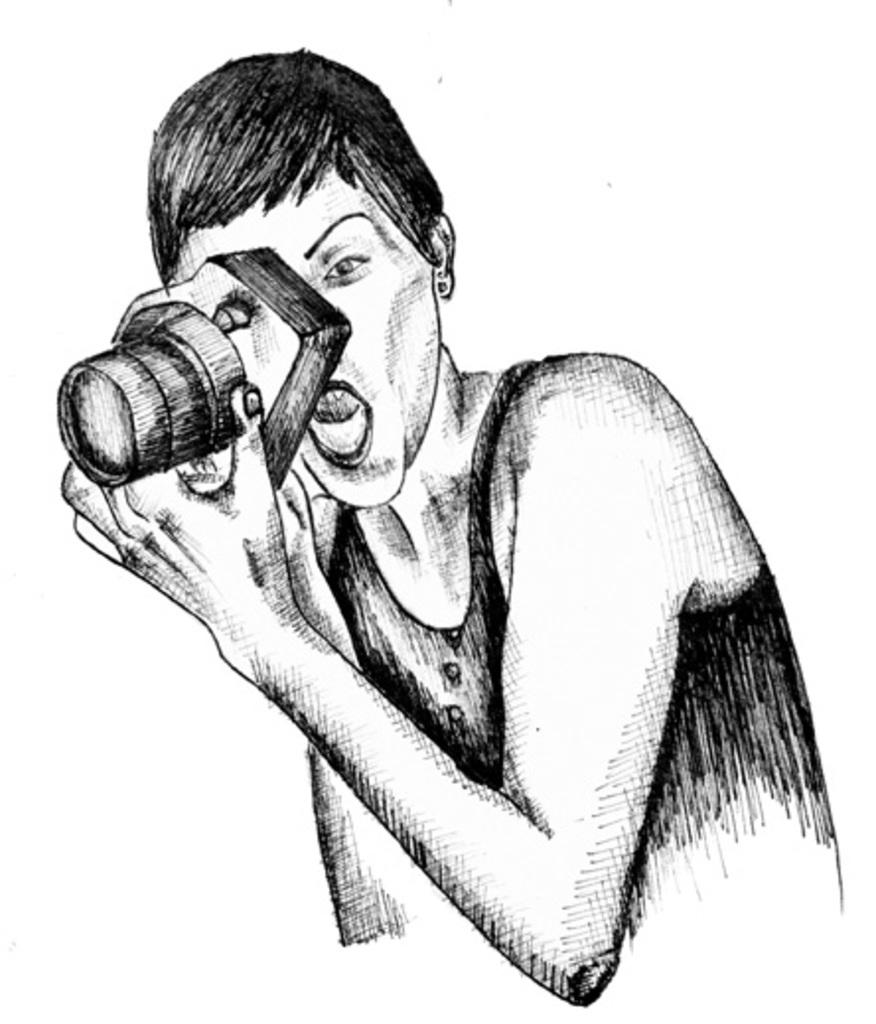What is depicted in the image? There is a sketch of a lady in the image. What is the lady holding in her hand? The lady is holding a camera in her hand. What type of eggnog is being served at the event in the image? There is no event or eggnog present in the image; it features a sketch of a lady holding a camera. What discovery was made by the lady in the image? There is no indication of a discovery in the image; it simply shows a lady holding a camera. 